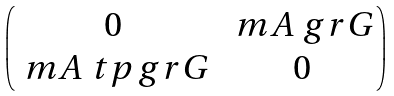Convert formula to latex. <formula><loc_0><loc_0><loc_500><loc_500>\begin{pmatrix} 0 & \ m A _ { \ } g r G \\ \ m A ^ { \ } t p _ { \ } g r G & 0 \end{pmatrix}</formula> 